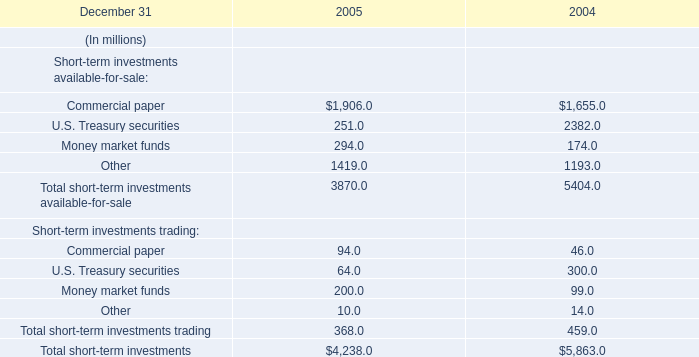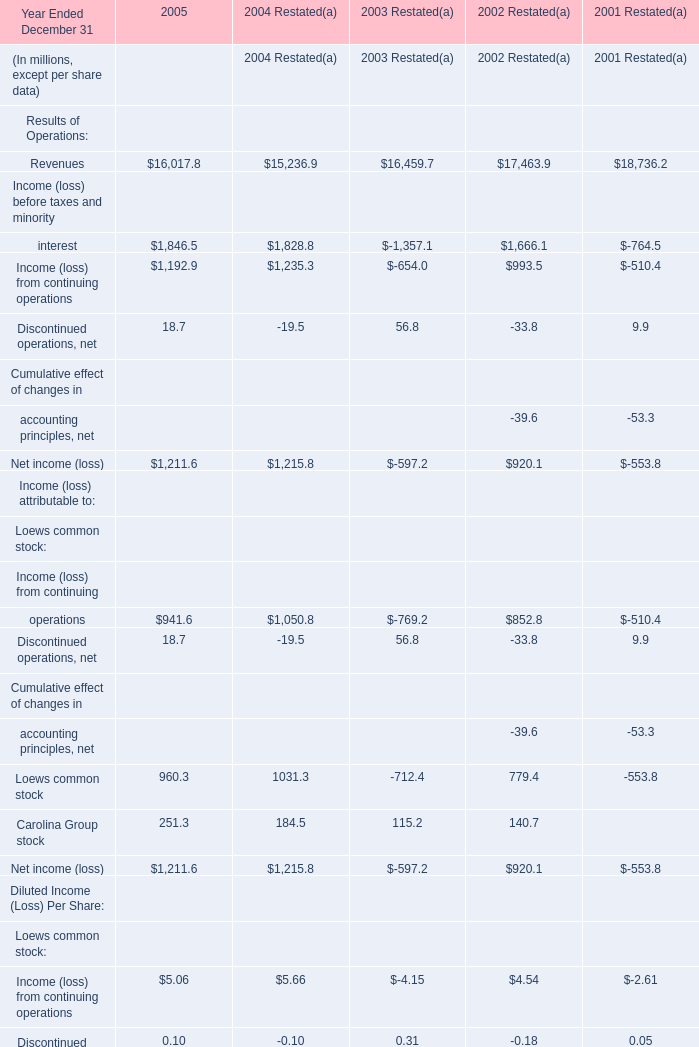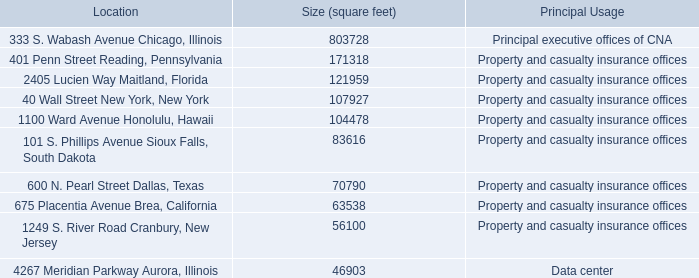In the section with the most Revenues of Operations, what is the value of Income (loss) from continuing operations as Results of Operations? (in million) 
Answer: -510.4. 